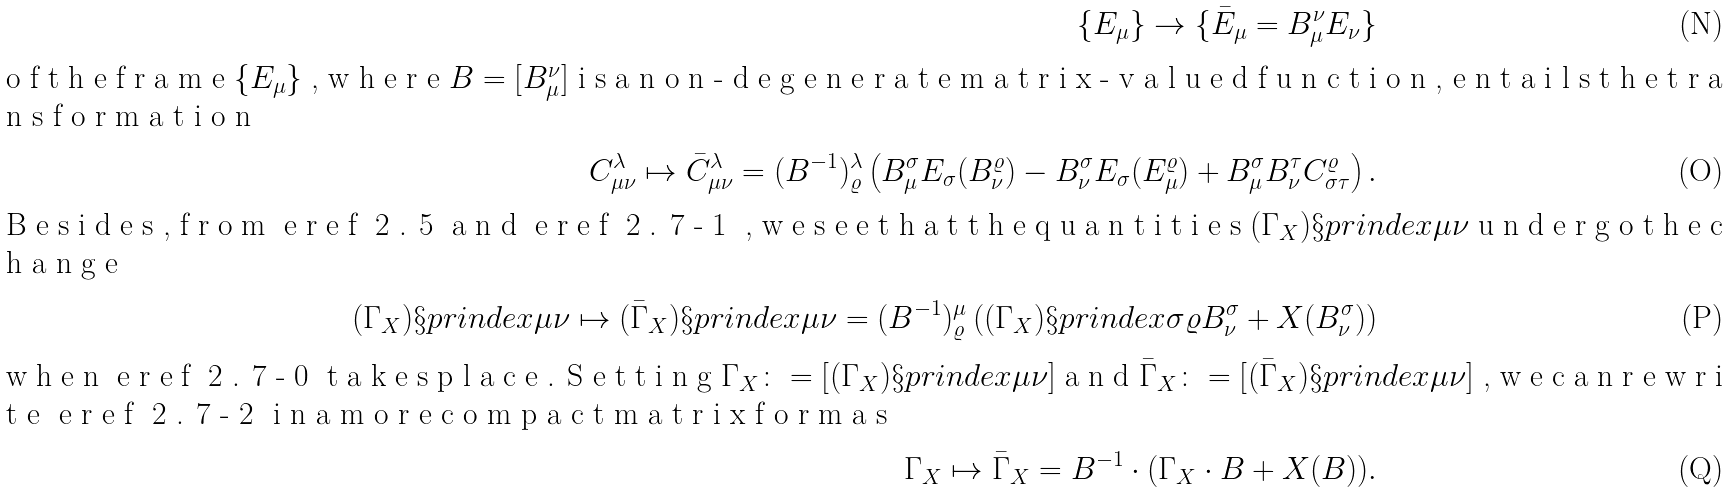Convert formula to latex. <formula><loc_0><loc_0><loc_500><loc_500>\{ E _ { \mu } \} \to \{ \bar { E } _ { \mu } = B _ { \mu } ^ { \nu } E _ { \nu } \} \\ \intertext { o f t h e f r a m e $ \{ E _ { \mu } \} $ , w h e r e $ B = [ B _ { \mu } ^ { \nu } ] $ i s a n o n - d e g e n e r a t e m a t r i x - v a l u e d f u n c t i o n , e n t a i l s t h e t r a n s f o r m a t i o n } C _ { \mu \nu } ^ { \lambda } \mapsto \bar { C } _ { \mu \nu } ^ { \lambda } = ( B ^ { - 1 } ) _ { \varrho } ^ { \lambda } \left ( B _ { \mu } ^ { \sigma } E _ { \sigma } ( B _ { \nu } ^ { \varrho } ) - B _ { \nu } ^ { \sigma } E _ { \sigma } ( E _ { \mu } ^ { \varrho } ) + B _ { \mu } ^ { \sigma } B _ { \nu } ^ { \tau } C _ { \sigma \tau } ^ { \varrho } \right ) . \\ \intertext { B e s i d e s , f r o m \ e r e f { 2 . 5 } a n d \ e r e f { 2 . 7 - 1 } , w e s e e t h a t t h e q u a n t i t i e s $ ( \Gamma _ { X } ) \S p r i n d e x { \mu } { \nu } $ u n d e r g o t h e c h a n g e } ( \Gamma _ { X } ) \S p r i n d e x { \mu } { \nu } \mapsto ( \bar { \Gamma } _ { X } ) \S p r i n d e x { \mu } { \nu } = ( B ^ { - 1 } ) _ { \varrho } ^ { \mu } \left ( ( \Gamma _ { X } ) \S p r i n d e x { \sigma } { \varrho } B _ { \nu } ^ { \sigma } + X ( B _ { \nu } ^ { \sigma } ) \right ) \\ \intertext { w h e n \ e r e f { 2 . 7 - 0 } t a k e s p l a c e . S e t t i n g $ \Gamma _ { X } \colon = [ ( \Gamma _ { X } ) \S p r i n d e x { \mu } { \nu } ] $ a n d $ \bar { \Gamma } _ { X } \colon = [ ( \bar { \Gamma } _ { X } ) \S p r i n d e x { \mu } { \nu } ] $ , w e c a n r e w r i t e \ e r e f { 2 . 7 - 2 } i n a m o r e c o m p a c t m a t r i x f o r m a s } \Gamma _ { X } \mapsto \bar { \Gamma } _ { X } = B ^ { - 1 } \cdot ( \Gamma _ { X } \cdot B + X ( B ) ) .</formula> 